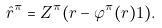<formula> <loc_0><loc_0><loc_500><loc_500>\hat { r } ^ { \pi } = Z ^ { \pi } ( r - \varphi ^ { \pi } ( r ) 1 ) .</formula> 